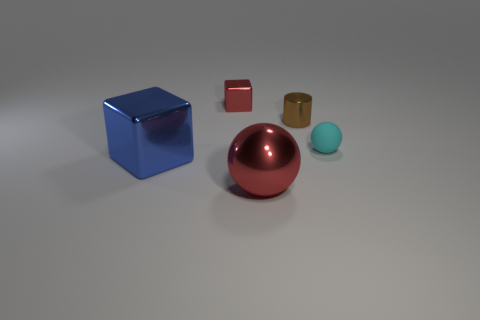Add 5 blue spheres. How many objects exist? 10 Subtract all spheres. How many objects are left? 3 Add 1 matte balls. How many matte balls exist? 2 Subtract 1 cyan spheres. How many objects are left? 4 Subtract all small objects. Subtract all matte things. How many objects are left? 1 Add 5 big balls. How many big balls are left? 6 